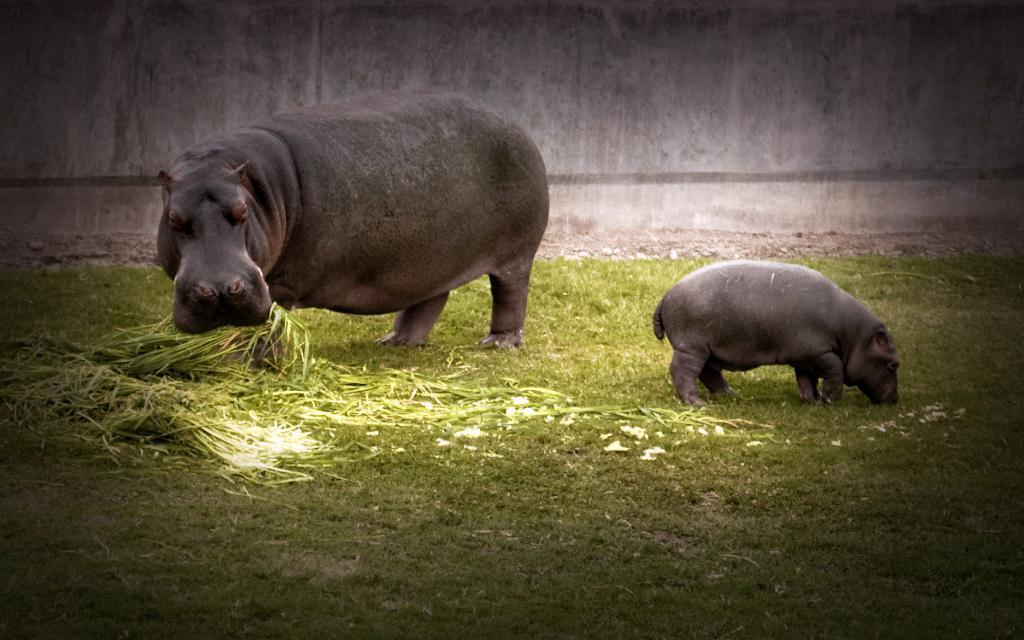In one or two sentences, can you explain what this image depicts? In this image we can see two animals on the ground. One animal is holding grass with its mouth. 